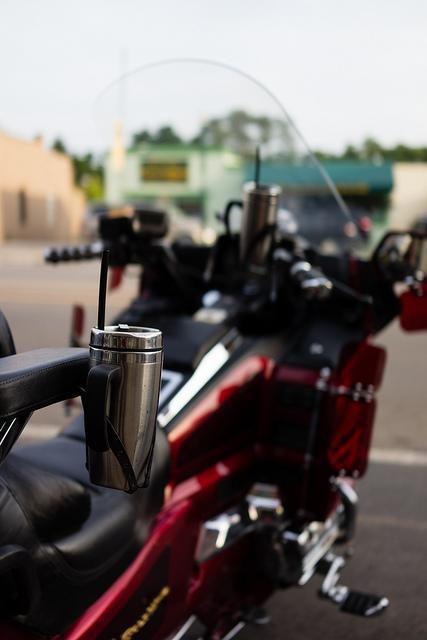How many cups are in the photo?
Give a very brief answer. 2. 